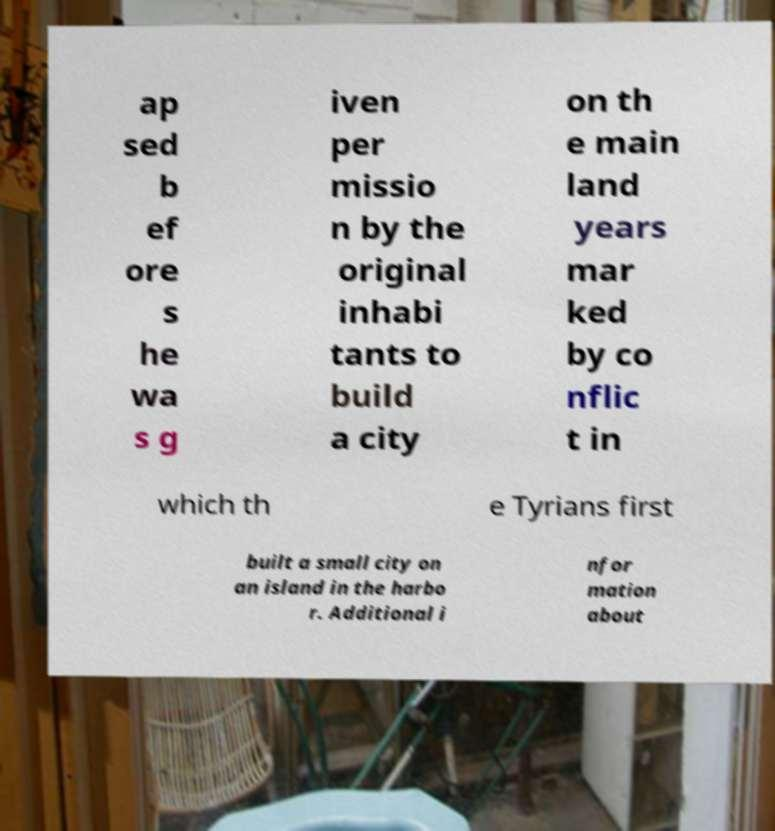What messages or text are displayed in this image? I need them in a readable, typed format. ap sed b ef ore s he wa s g iven per missio n by the original inhabi tants to build a city on th e main land years mar ked by co nflic t in which th e Tyrians first built a small city on an island in the harbo r. Additional i nfor mation about 